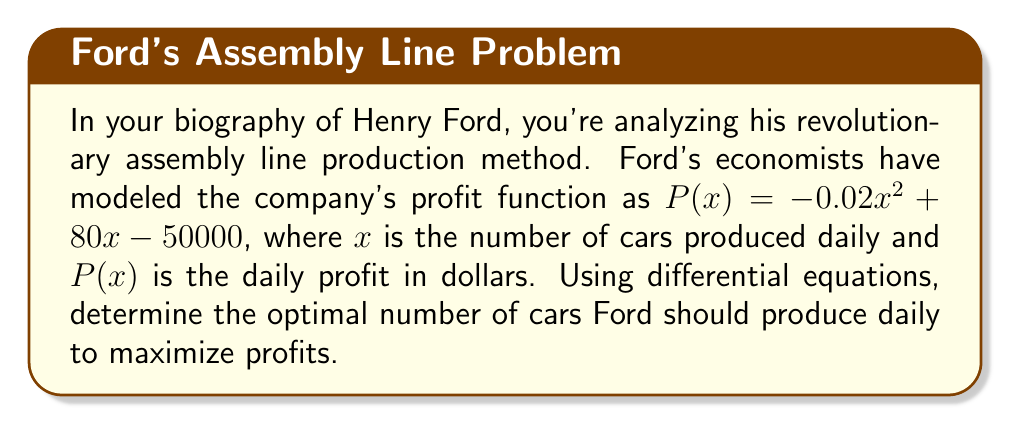Give your solution to this math problem. To find the optimal production rate that maximizes profits, we need to find the maximum of the profit function $P(x)$. This can be done by finding the point where the derivative of $P(x)$ equals zero.

1. First, let's find the derivative of $P(x)$:
   $$P'(x) = \frac{d}{dx}(-0.02x^2 + 80x - 50000)$$
   $$P'(x) = -0.04x + 80$$

2. To find the maximum, set $P'(x) = 0$:
   $$-0.04x + 80 = 0$$

3. Solve for $x$:
   $$-0.04x = -80$$
   $$x = \frac{-80}{-0.04} = 2000$$

4. To confirm this is a maximum (not a minimum), check the second derivative:
   $$P''(x) = \frac{d}{dx}(-0.04x + 80) = -0.04$$
   Since $P''(x)$ is negative, this confirms we have found a maximum.

5. Therefore, the optimal number of cars to produce daily is 2000.

6. We can calculate the maximum daily profit by substituting $x = 2000$ into the original profit function:
   $$P(2000) = -0.02(2000)^2 + 80(2000) - 50000$$
   $$= -80000 + 160000 - 50000$$
   $$= 30000$$

Thus, the maximum daily profit is $30,000.
Answer: Ford should produce 2000 cars daily to maximize profits, resulting in a maximum daily profit of $30,000. 